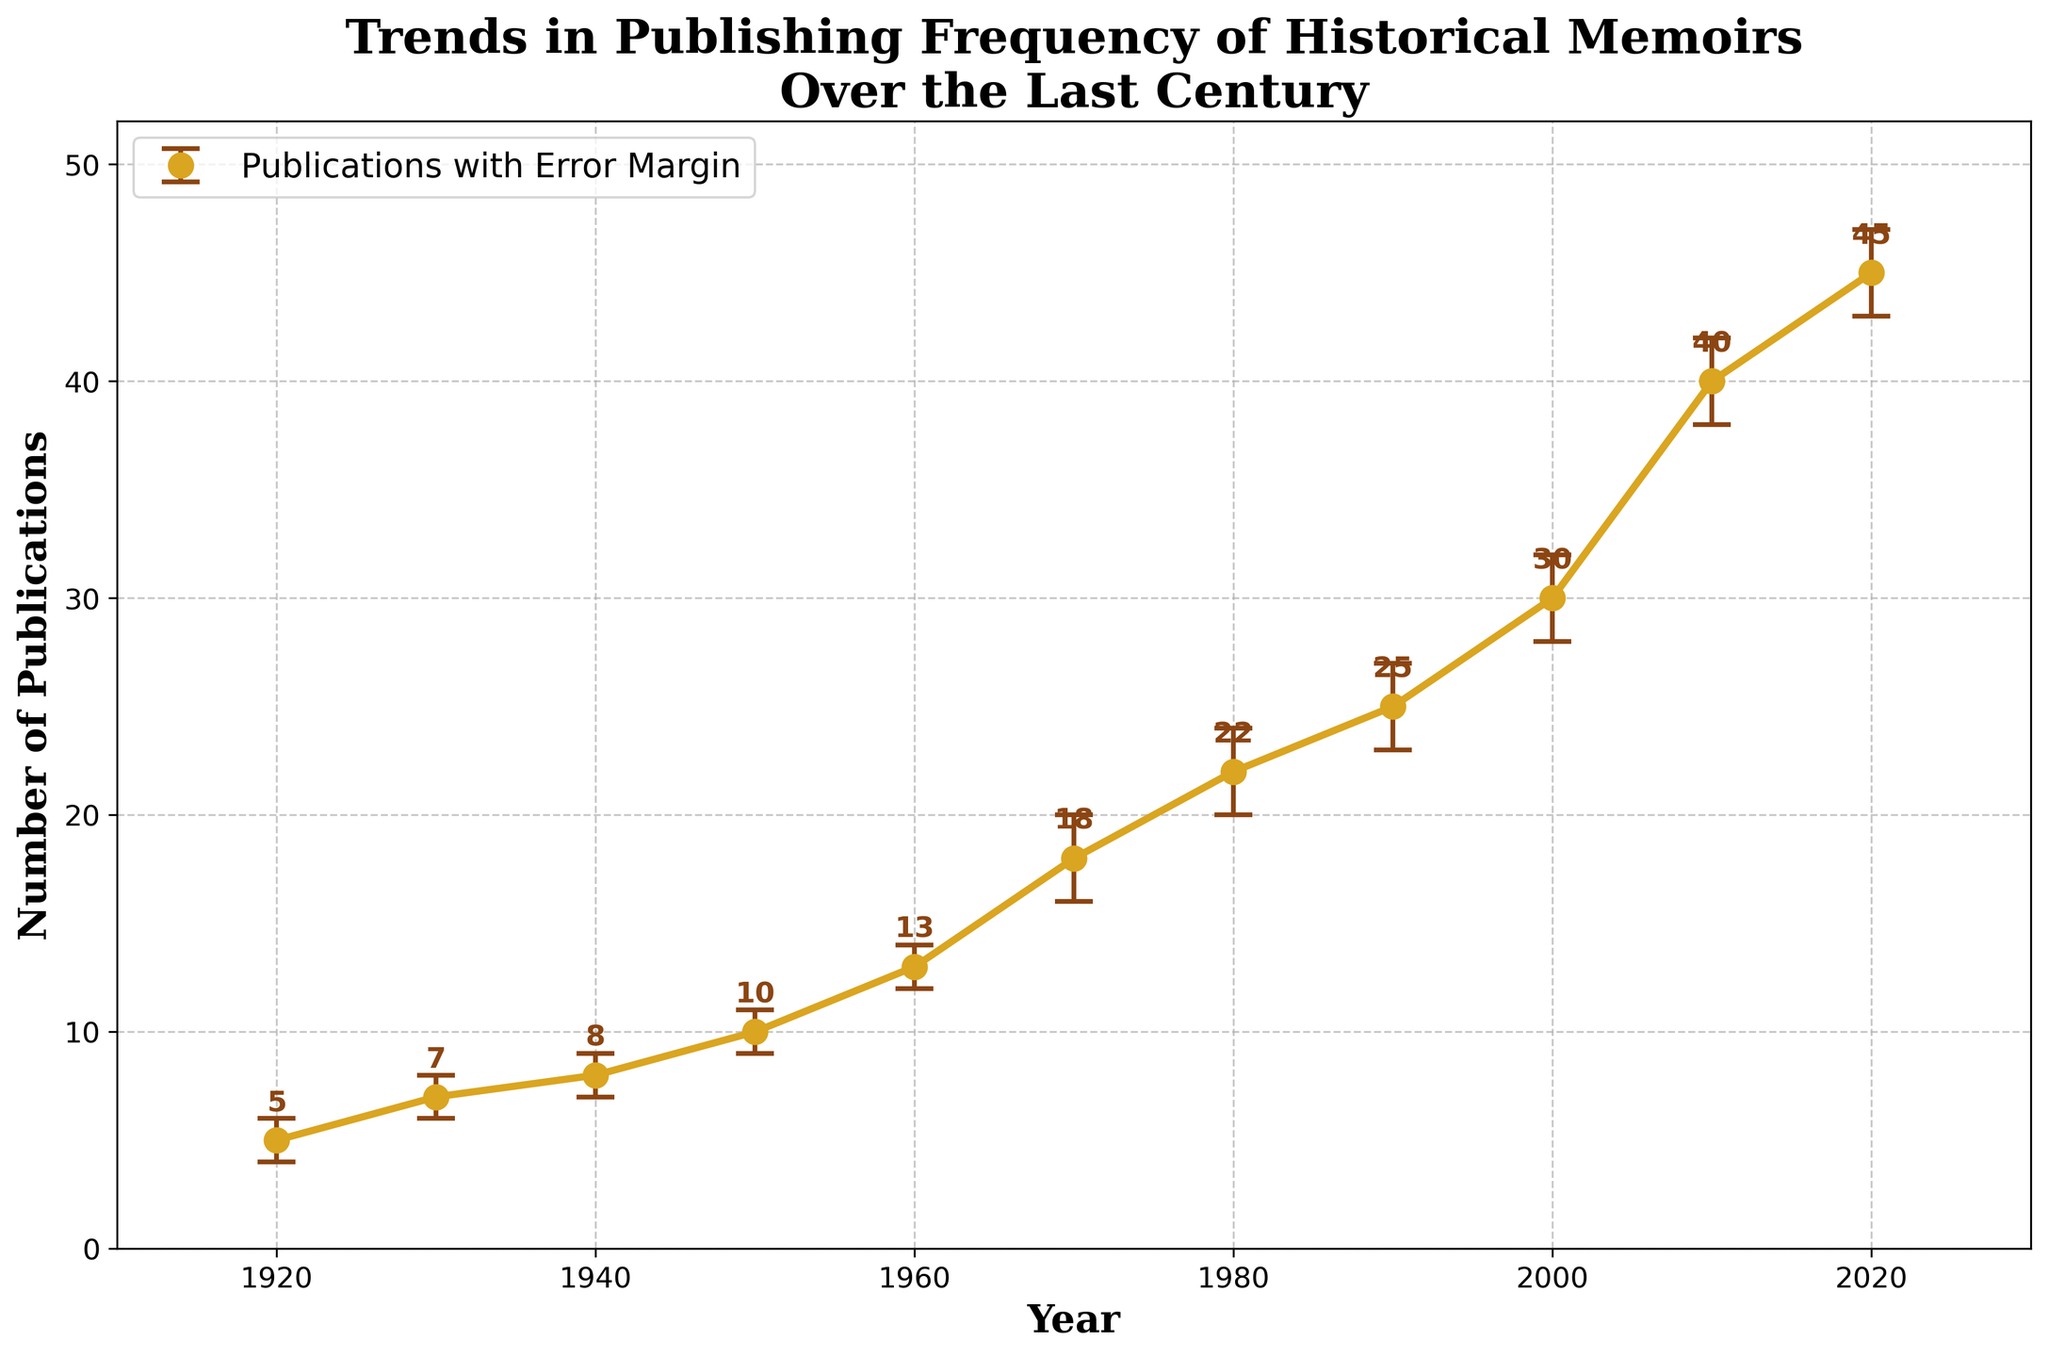What's the title of the figure? The title is located at the top of the figure, usually in larger and bold font. It summarizes the main topic of the plot, making it clear what the data represents.
Answer: Trends in Publishing Frequency of Historical Memoirs Over the Last Century How many data points are shown in the plot? Each data point corresponds to a year listed on the x-axis. By counting the distinct years, we can determine the number of data points.
Answer: 11 What is the range of publication frequencies in the plot? The plot shows the lowest and highest publication frequencies by examining the y-axis values between the minimum and maximum points.
Answer: 5 to 45 Which year had the highest mean number of publications? The highest mean number of publications can be found by identifying the peak point in the plot.
Answer: 2020 Between which two consecutive decades did the mean number of publications increase the most? To find the biggest increase, we need to calculate the difference in publication numbers between each consecutive pair of decades and identify the largest.
Answer: 2000 to 2010 What is the mean number of publications in 1960 and its error margin? By locating 1960 on the x-axis and reading the corresponding y value, we find the mean number, and the error margin can be determined from the error bars.
Answer: 13 (error margin +1, -1) By how much did the mean number of publications increase between 1920 and 2020? Subtract the mean number of publications in 1920 from that in 2020 to determine the increase.
Answer: 40 Between which two decades did the error margins show the largest range? The error margin ranges are found by subtracting the lower error from the upper error for each decade, then identifying the largest difference.
Answer: 1970 to 1980 In what decade did the number of publications exceed 20 for the first time? By examining the y-values in the plot, we find the first time the value crosses the 20 mark and identify the corresponding decade.
Answer: 1980 Which year had the smallest error margin on reported publication dates? The smallest error margin is the narrowest range between the lower and upper error bars. We identify the year by comparing the ranges.
Answer: 1940 